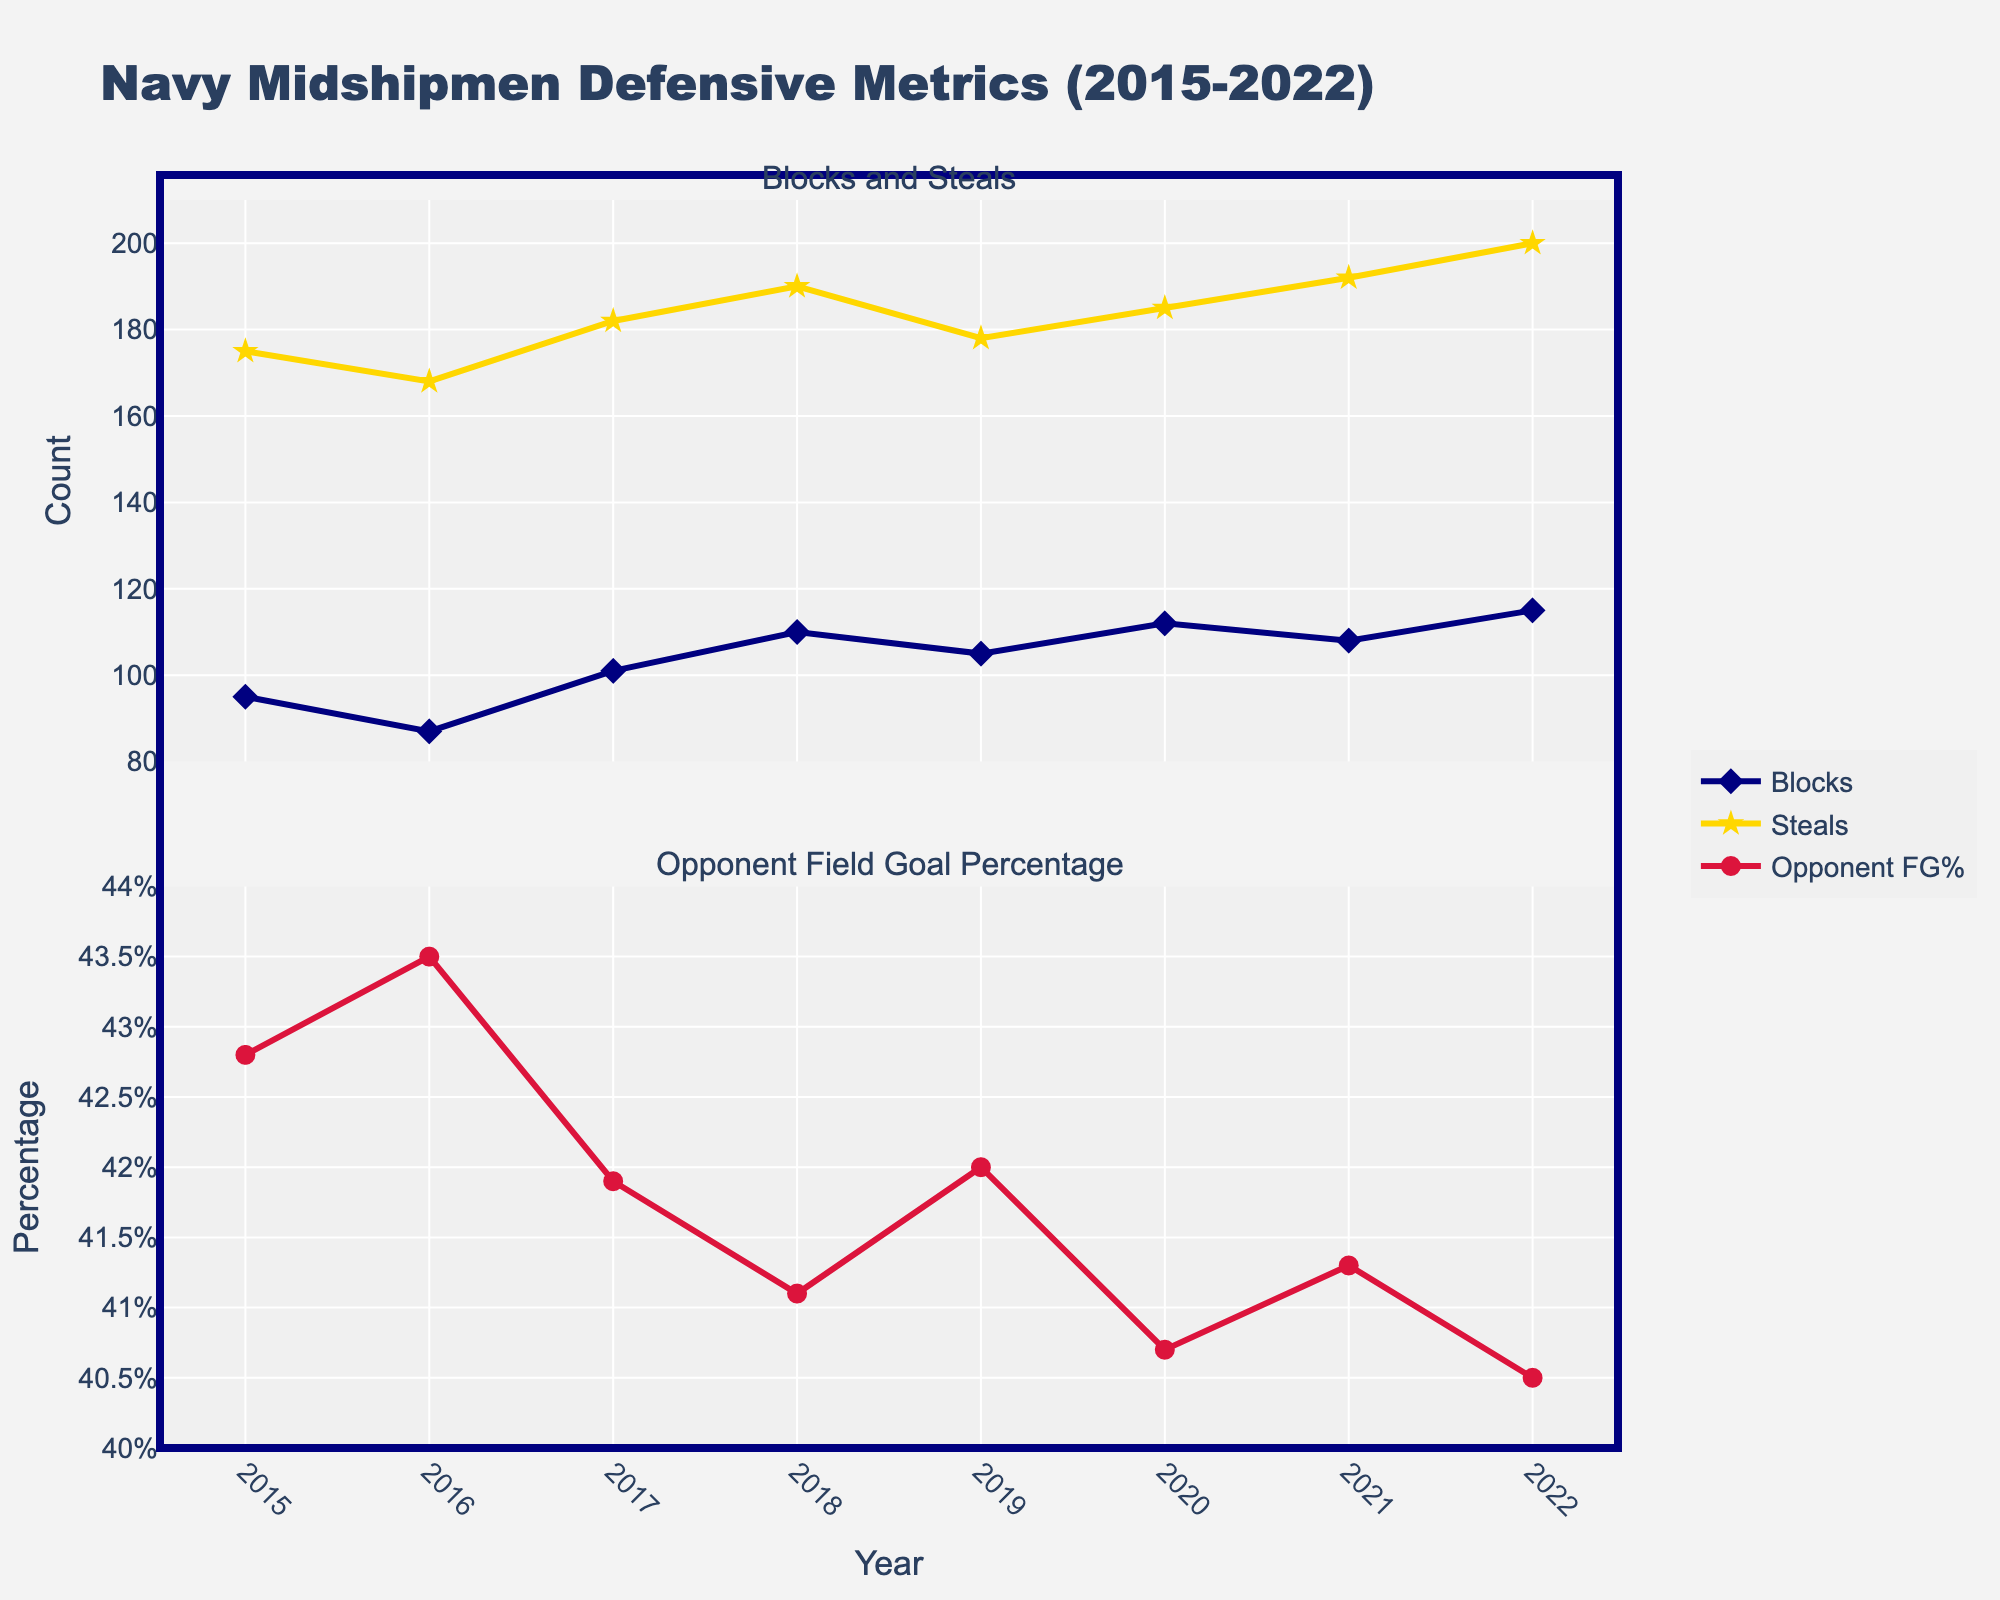What's the title of the plot? The title is displayed at the top of the figure. It reads "Navy Midshipmen Defensive Metrics (2015-2022)."
Answer: Navy Midshipmen Defensive Metrics (2015-2022) How many metrics are visualized in the plot? There are three different metrics shown in the plot: Blocks, Steals, and Opponent Field Goal Percentage.
Answer: 3 In which year did the Navy Midshipmen have the highest number of steals? By examining the "Blocks and Steals" subplot, we can identify that the year 2022 shows the highest number of steals with a value of 200.
Answer: 2022 What is the trend of the Opponent Field Goal Percentage from 2015 to 2022? By observing the "Opponent Field Goal Percentage" subplot, the overall trend is a decrease, starting from 42.8% in 2015 to 40.5% in 2022.
Answer: Decreasing Which year had the lowest Opponent Field Goal Percentage, and what was the percentage? By checking the "Opponent Field Goal Percentage" subplot, the year 2022 had the lowest Opponent Field Goal Percentage at 40.5%.
Answer: 2022, 40.5% Compare the number of blocks in 2016 and 2020. Which year had more, and by how much? From the "Blocks and Steals" subplot, 2020 had 112 blocks, while 2016 had 87 blocks. The difference is 112 - 87 = 25.
Answer: 2020, by 25 Calculate the average number of blocks per year over the period. Sum the number of blocks from each year (95+87+101+110+105+112+108+115) and then divide by 8: (95+87+101+110+105+112+108+115) / 8 = 97.75.
Answer: 97.75 In which year does the Opponent Field Goal Percentage first drop below 42%? Looking at the "Opponent Field Goal Percentage" subplot, this first occurs in 2017 when the percentage is 41.9%.
Answer: 2017 What is the relationship between the number of steals and blocks in 2018? From the "Blocks and Steals" subplot, 2018 shows 110 blocks and 190 steals. The relationship can be described as the number of steals being considerably higher than the number of blocks.
Answer: Steals > Blocks Between which consecutive years was the largest increase in blocks observed? By comparing blocks year-to-year in the "Blocks and Steals" subplot, the largest increase occurs between 2015 (95) and 2017 (101 + 110). The increase from 2017 to 2018 (110 - 86 = 24).
Answer: 2015-2017 